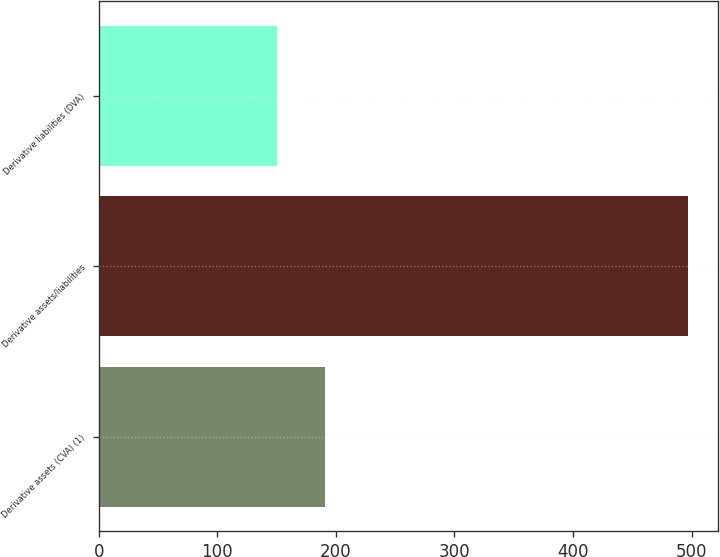<chart> <loc_0><loc_0><loc_500><loc_500><bar_chart><fcel>Derivative assets (CVA) (1)<fcel>Derivative assets/liabilities<fcel>Derivative liabilities (DVA)<nl><fcel>191<fcel>497<fcel>150<nl></chart> 